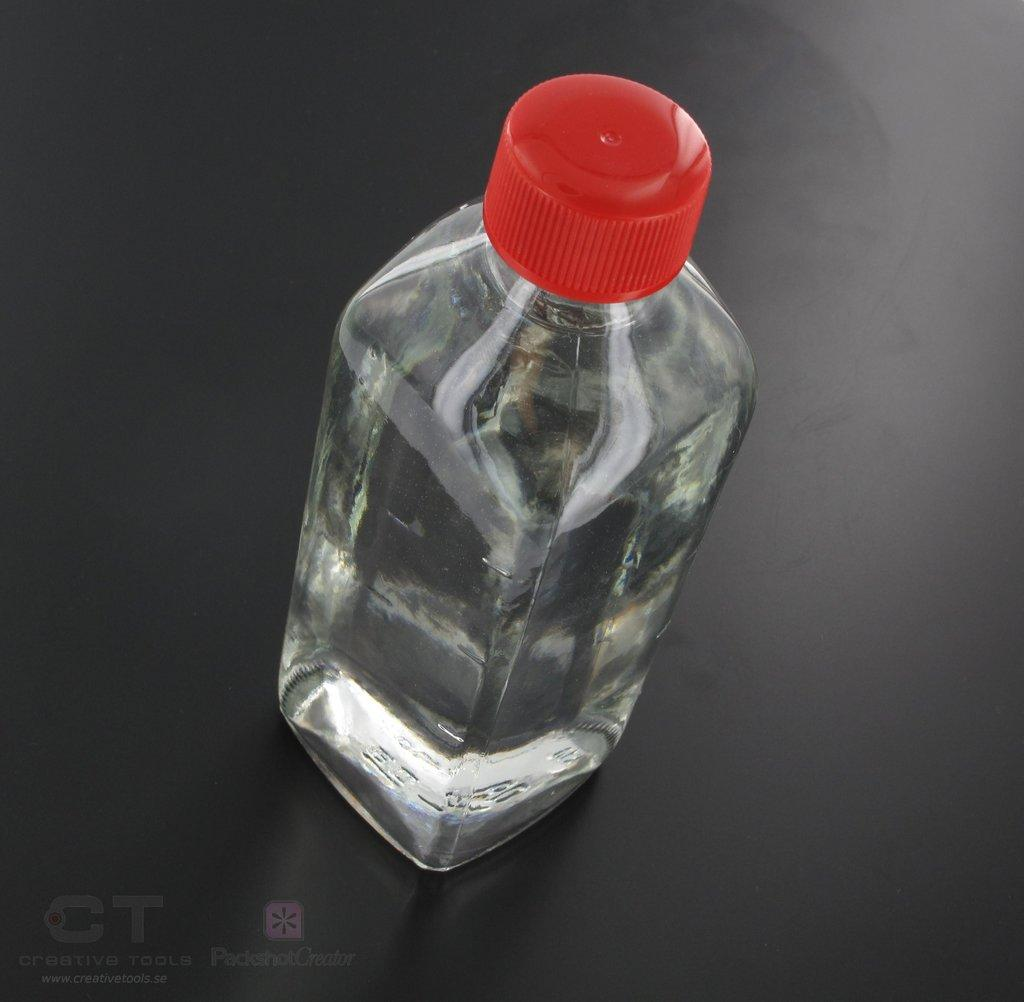What object can be seen in the picture? There is a bottle in the picture. What color is the cap of the bottle? The bottle has a red cap. What is the material of the bottle? The bottle is transparent. What is inside the bottle? There is water inside the bottle. How many years has the bottle been sailing in the image? There is no indication of sailing or time in the image, as it only features a bottle with a red cap and water inside. 